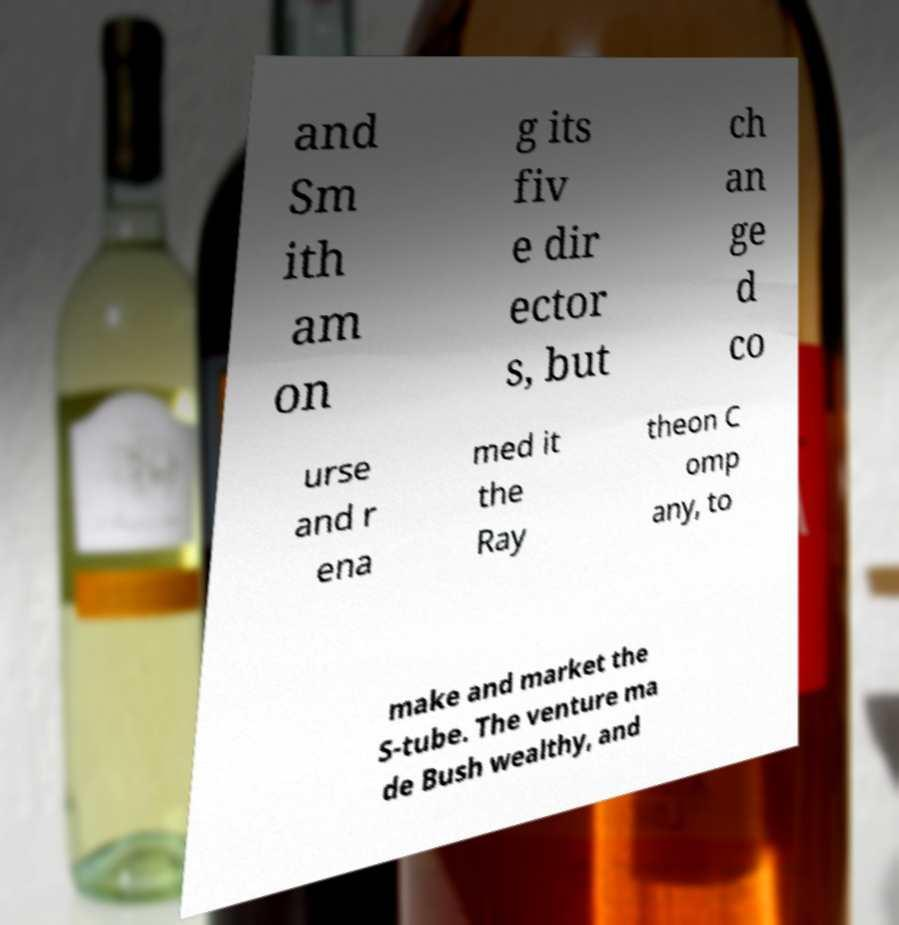I need the written content from this picture converted into text. Can you do that? and Sm ith am on g its fiv e dir ector s, but ch an ge d co urse and r ena med it the Ray theon C omp any, to make and market the S-tube. The venture ma de Bush wealthy, and 